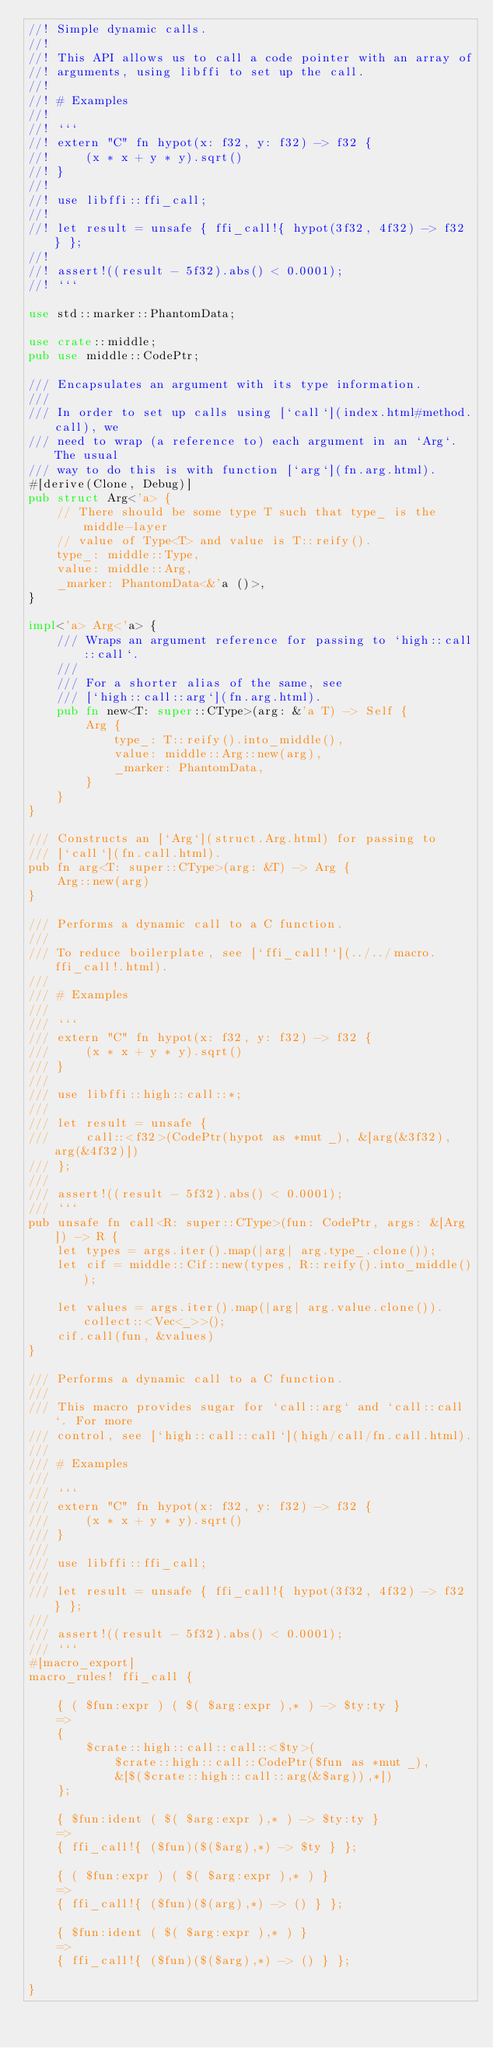Convert code to text. <code><loc_0><loc_0><loc_500><loc_500><_Rust_>//! Simple dynamic calls.
//!
//! This API allows us to call a code pointer with an array of
//! arguments, using libffi to set up the call.
//!
//! # Examples
//!
//! ```
//! extern "C" fn hypot(x: f32, y: f32) -> f32 {
//!     (x * x + y * y).sqrt()
//! }
//!
//! use libffi::ffi_call;
//!
//! let result = unsafe { ffi_call!{ hypot(3f32, 4f32) -> f32 } };
//!
//! assert!((result - 5f32).abs() < 0.0001);
//! ```

use std::marker::PhantomData;

use crate::middle;
pub use middle::CodePtr;

/// Encapsulates an argument with its type information.
///
/// In order to set up calls using [`call`](index.html#method.call), we
/// need to wrap (a reference to) each argument in an `Arg`. The usual
/// way to do this is with function [`arg`](fn.arg.html).
#[derive(Clone, Debug)]
pub struct Arg<'a> {
    // There should be some type T such that type_ is the middle-layer
    // value of Type<T> and value is T::reify().
    type_: middle::Type,
    value: middle::Arg,
    _marker: PhantomData<&'a ()>,
}

impl<'a> Arg<'a> {
    /// Wraps an argument reference for passing to `high::call::call`.
    ///
    /// For a shorter alias of the same, see
    /// [`high::call::arg`](fn.arg.html).
    pub fn new<T: super::CType>(arg: &'a T) -> Self {
        Arg {
            type_: T::reify().into_middle(),
            value: middle::Arg::new(arg),
            _marker: PhantomData,
        }
    }
}

/// Constructs an [`Arg`](struct.Arg.html) for passing to
/// [`call`](fn.call.html).
pub fn arg<T: super::CType>(arg: &T) -> Arg {
    Arg::new(arg)
}

/// Performs a dynamic call to a C function.
///
/// To reduce boilerplate, see [`ffi_call!`](../../macro.ffi_call!.html).
///
/// # Examples
///
/// ```
/// extern "C" fn hypot(x: f32, y: f32) -> f32 {
///     (x * x + y * y).sqrt()
/// }
///
/// use libffi::high::call::*;
///
/// let result = unsafe {
///     call::<f32>(CodePtr(hypot as *mut _), &[arg(&3f32), arg(&4f32)])
/// };
///
/// assert!((result - 5f32).abs() < 0.0001);
/// ```
pub unsafe fn call<R: super::CType>(fun: CodePtr, args: &[Arg]) -> R {
    let types = args.iter().map(|arg| arg.type_.clone());
    let cif = middle::Cif::new(types, R::reify().into_middle());

    let values = args.iter().map(|arg| arg.value.clone()).collect::<Vec<_>>();
    cif.call(fun, &values)
}

/// Performs a dynamic call to a C function.
///
/// This macro provides sugar for `call::arg` and `call::call`. For more
/// control, see [`high::call::call`](high/call/fn.call.html).
///
/// # Examples
///
/// ```
/// extern "C" fn hypot(x: f32, y: f32) -> f32 {
///     (x * x + y * y).sqrt()
/// }
///
/// use libffi::ffi_call;
///
/// let result = unsafe { ffi_call!{ hypot(3f32, 4f32) -> f32 } };
///
/// assert!((result - 5f32).abs() < 0.0001);
/// ```
#[macro_export]
macro_rules! ffi_call {

    { ( $fun:expr ) ( $( $arg:expr ),* ) -> $ty:ty }
    =>
    {
        $crate::high::call::call::<$ty>(
            $crate::high::call::CodePtr($fun as *mut _),
            &[$($crate::high::call::arg(&$arg)),*])
    };

    { $fun:ident ( $( $arg:expr ),* ) -> $ty:ty }
    =>
    { ffi_call!{ ($fun)($($arg),*) -> $ty } };

    { ( $fun:expr ) ( $( $arg:expr ),* ) }
    =>
    { ffi_call!{ ($fun)($(arg),*) -> () } };

    { $fun:ident ( $( $arg:expr ),* ) }
    =>
    { ffi_call!{ ($fun)($($arg),*) -> () } };

}
</code> 